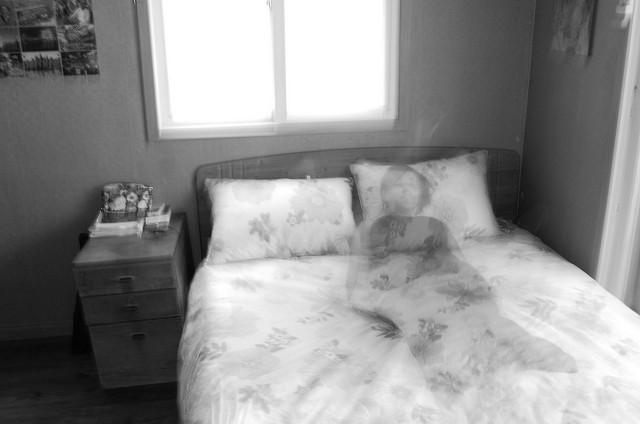The exposure makes the woman look like what? Please explain your reasoning. ghost. The woman looks like a ghost due to the camera. 